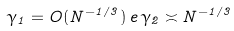<formula> <loc_0><loc_0><loc_500><loc_500>\gamma _ { 1 } = O ( N ^ { - 1 / 3 } ) \, e \, \gamma _ { 2 } \asymp N ^ { - 1 / 3 }</formula> 